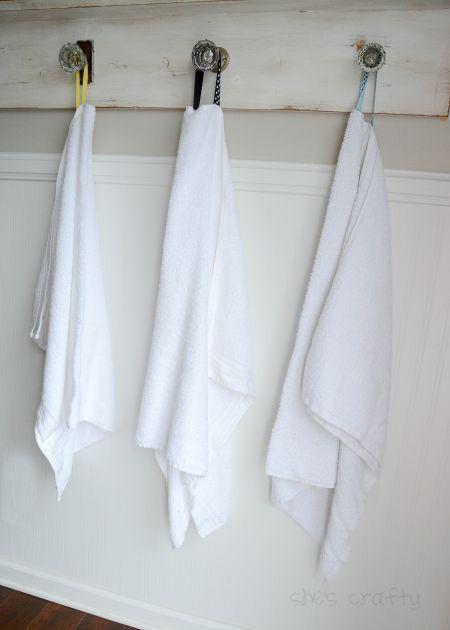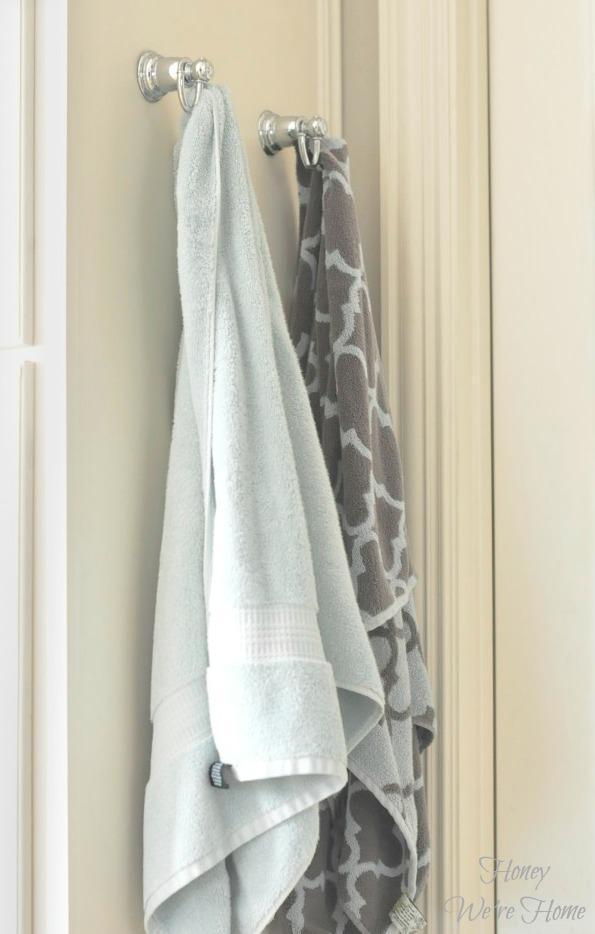The first image is the image on the left, the second image is the image on the right. Evaluate the accuracy of this statement regarding the images: "In one of the images there is a single white towel hanging on a towel bar.". Is it true? Answer yes or no. No. 